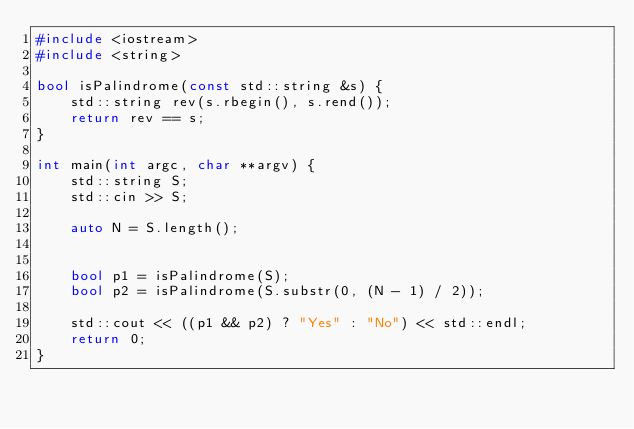Convert code to text. <code><loc_0><loc_0><loc_500><loc_500><_C++_>#include <iostream>
#include <string>

bool isPalindrome(const std::string &s) {
    std::string rev(s.rbegin(), s.rend());
    return rev == s;
}

int main(int argc, char **argv) {
    std::string S;
    std::cin >> S;

    auto N = S.length();


    bool p1 = isPalindrome(S);
    bool p2 = isPalindrome(S.substr(0, (N - 1) / 2));

    std::cout << ((p1 && p2) ? "Yes" : "No") << std::endl;
    return 0;
}
</code> 